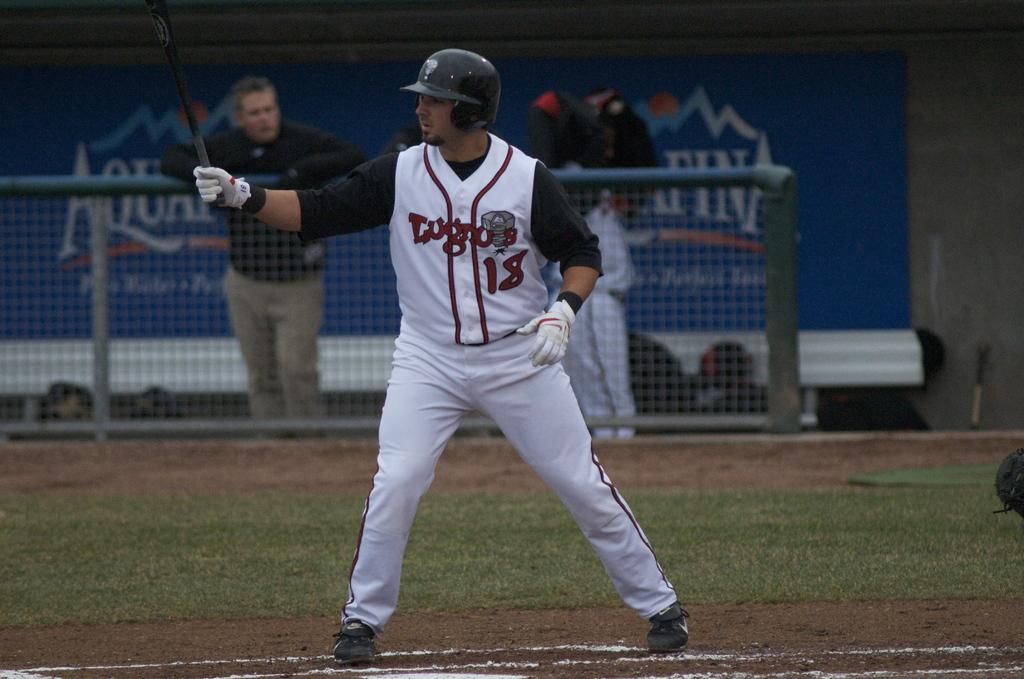<image>
Summarize the visual content of the image. A baseball player swings a bat in front of an Aquafina Ad. 